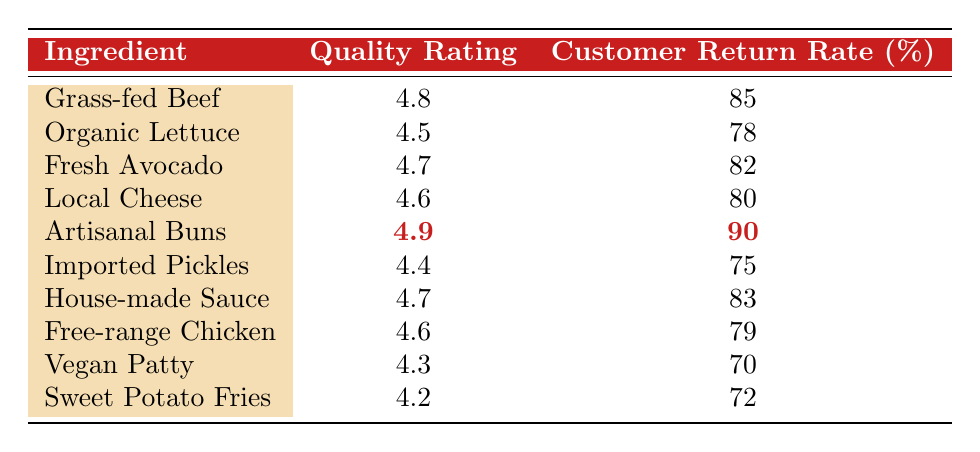What is the quality rating of Artisanal Buns? The table lists Artisanal Buns in the ingredient column, and its corresponding quality rating is directly next to it. According to the table, the quality rating is 4.9.
Answer: 4.9 Which ingredient has the highest customer return rate? By scanning the customer return rate column, Artisanal Buns has the highest value, which is 90 percent, higher than all other ingredients listed.
Answer: Artisanal Buns What is the average quality rating of all ingredients? To find the average, sum all the quality ratings: (4.8 + 4.5 + 4.7 + 4.6 + 4.9 + 4.4 + 4.7 + 4.6 + 4.3 + 4.2) = 46.7. There are 10 ingredients, so the average is 46.7/10 = 4.67.
Answer: 4.67 Is the quality rating of Vegan Patty greater than 4.5? The quality rating for Vegan Patty is 4.3, which is less than 4.5. Thus, the statement is false.
Answer: No How does the quality rating correlate with customer return rates? By examining the table, it can be observed that generally, as the quality rating increases, the customer return rate also tends to increase; for example, Artisanal Buns has both the highest quality and return rate, indicating a positive correlation.
Answer: Positive correlation 